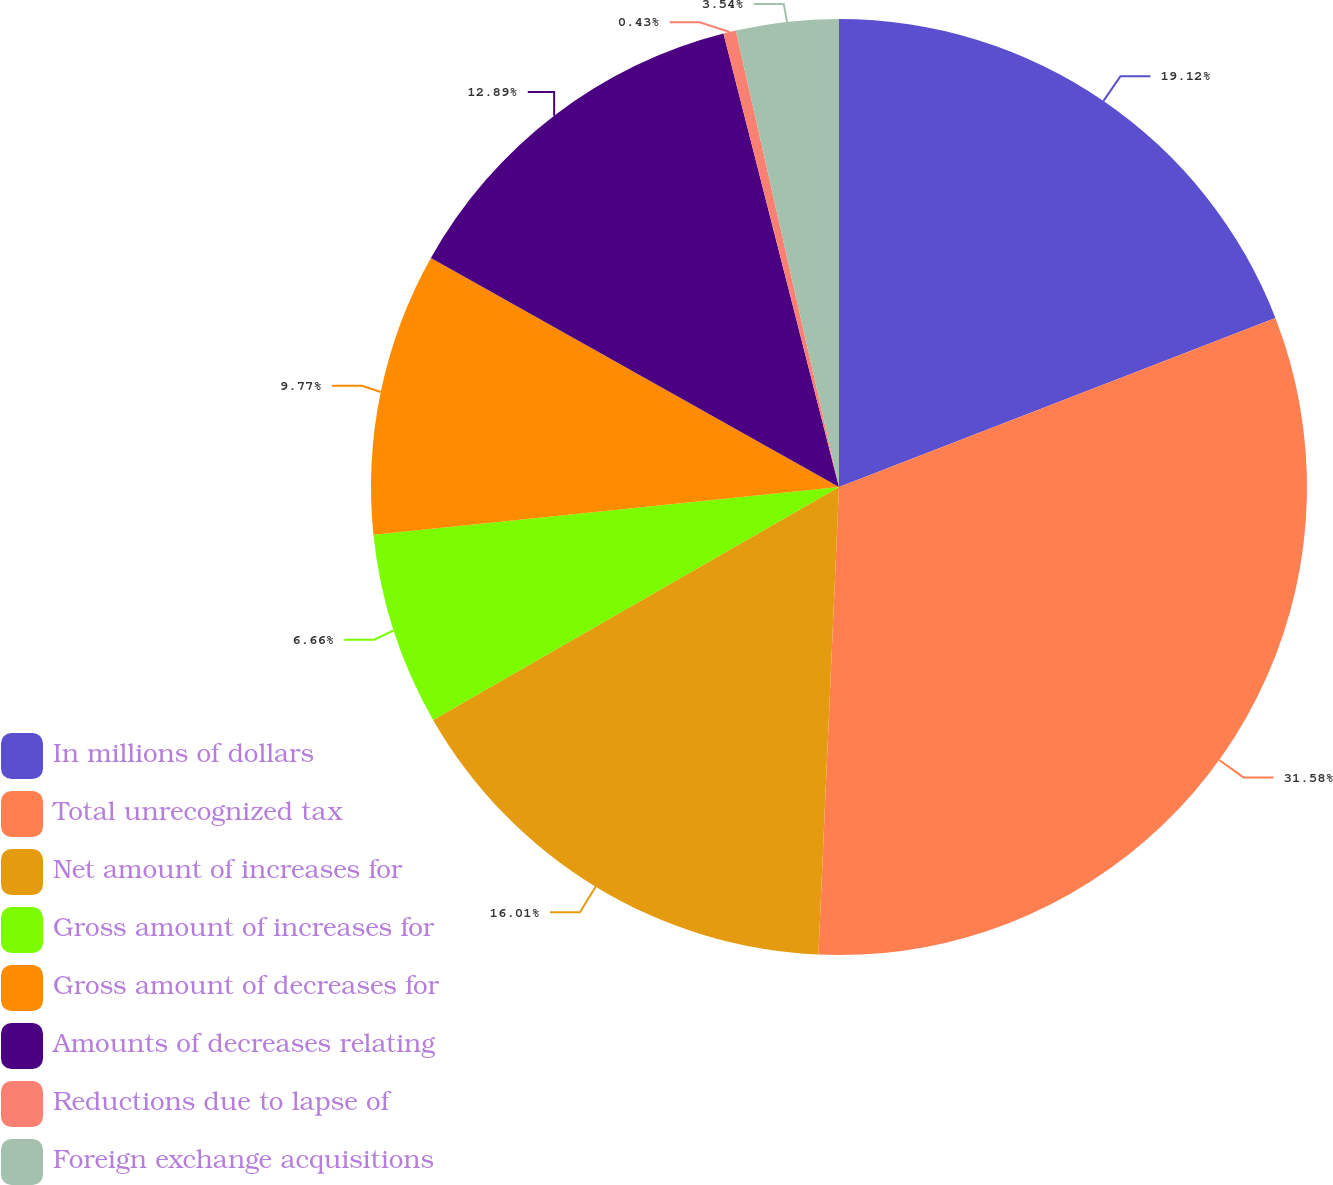Convert chart to OTSL. <chart><loc_0><loc_0><loc_500><loc_500><pie_chart><fcel>In millions of dollars<fcel>Total unrecognized tax<fcel>Net amount of increases for<fcel>Gross amount of increases for<fcel>Gross amount of decreases for<fcel>Amounts of decreases relating<fcel>Reductions due to lapse of<fcel>Foreign exchange acquisitions<nl><fcel>19.12%<fcel>31.58%<fcel>16.01%<fcel>6.66%<fcel>9.77%<fcel>12.89%<fcel>0.43%<fcel>3.54%<nl></chart> 